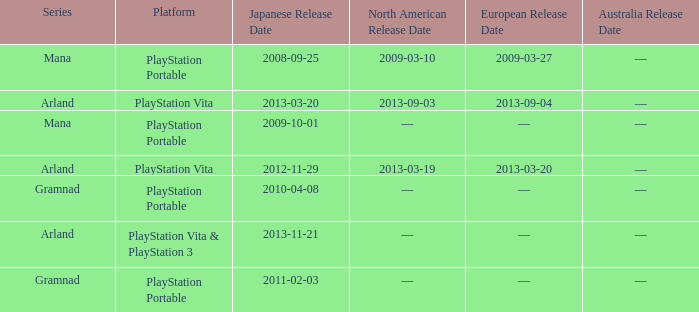What is the North American release date of the remake with a European release date on 2013-03-20? 2013-03-19. 